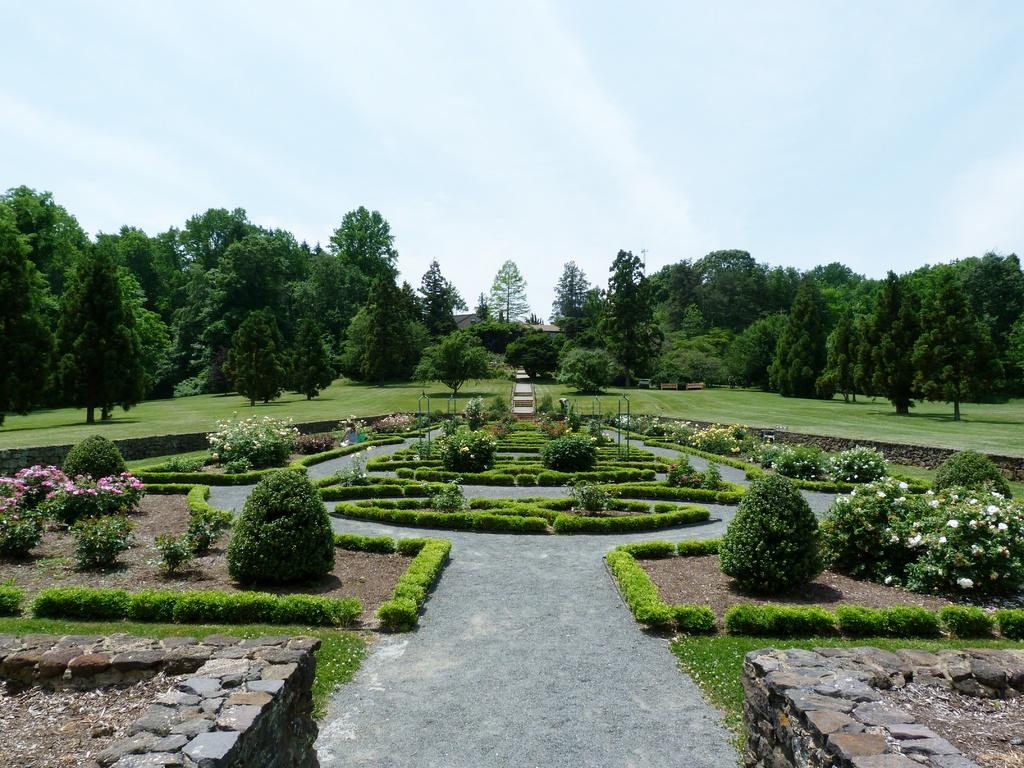What type of outdoor space is depicted in the image? There is a garden in the image. What are the walls of the garden made of? The garden has stone walls. What types of vegetation can be seen in the garden? There are plants and trees in the garden. What is the ground cover in the garden? There is grass in the garden. What additional structures are present in the garden? There are poles in the garden. What can be seen in the sky in the image? The sky is visible in the image. What type of jeans is the lettuce wearing in the image? There is no lettuce or jeans present in the image. What type of education is being provided in the garden? There is no indication of any educational activity taking place in the garden. 